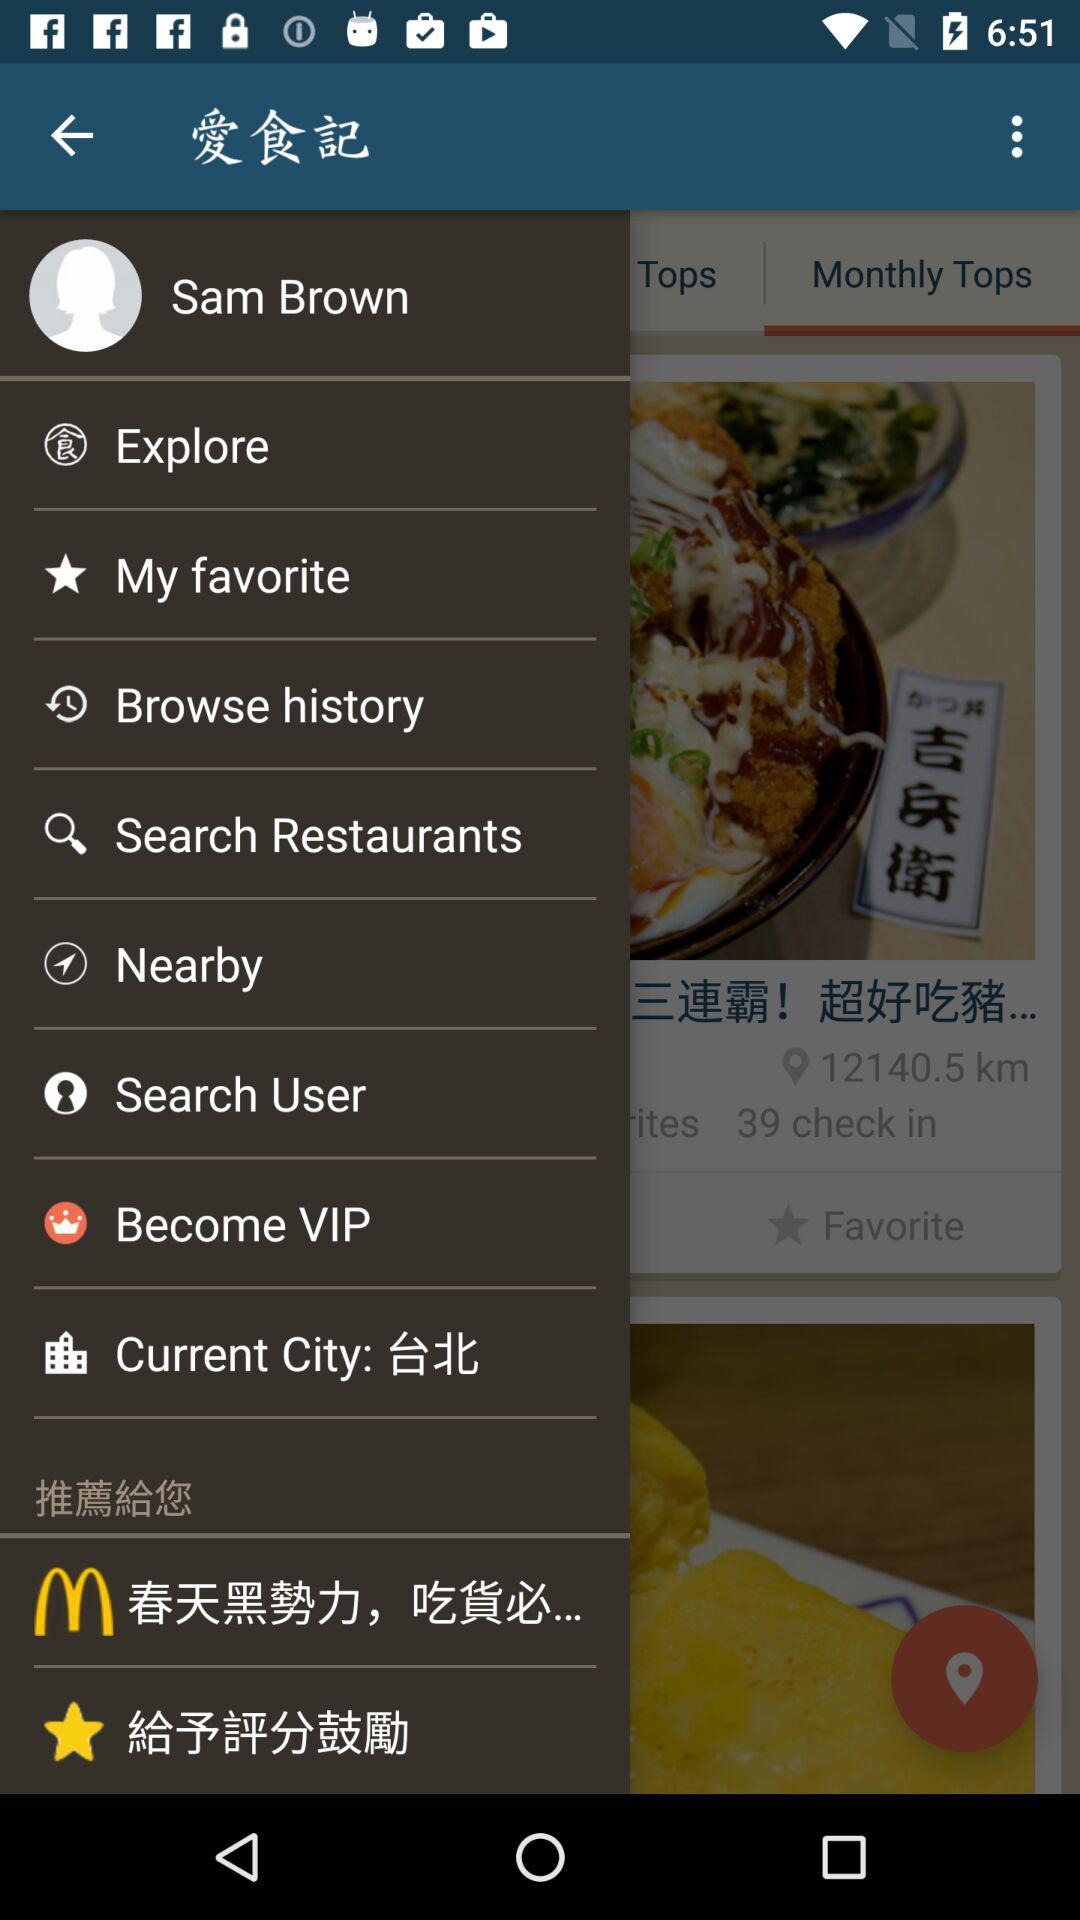What's the user profile name? The user profile name is "Sam Brown". 